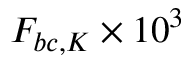Convert formula to latex. <formula><loc_0><loc_0><loc_500><loc_500>F _ { b c , K } \times 1 0 ^ { 3 }</formula> 